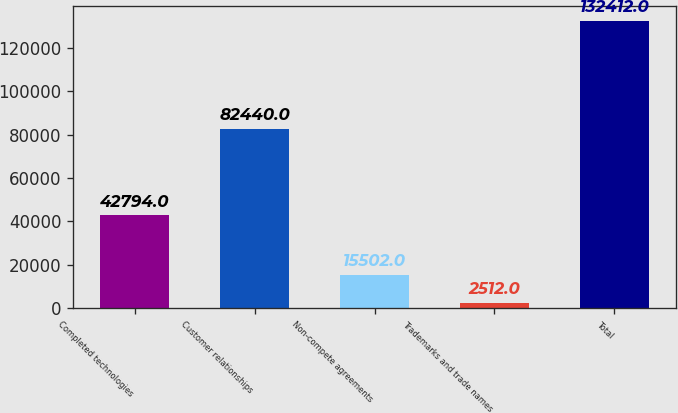<chart> <loc_0><loc_0><loc_500><loc_500><bar_chart><fcel>Completed technologies<fcel>Customer relationships<fcel>Non-compete agreements<fcel>Trademarks and trade names<fcel>Total<nl><fcel>42794<fcel>82440<fcel>15502<fcel>2512<fcel>132412<nl></chart> 